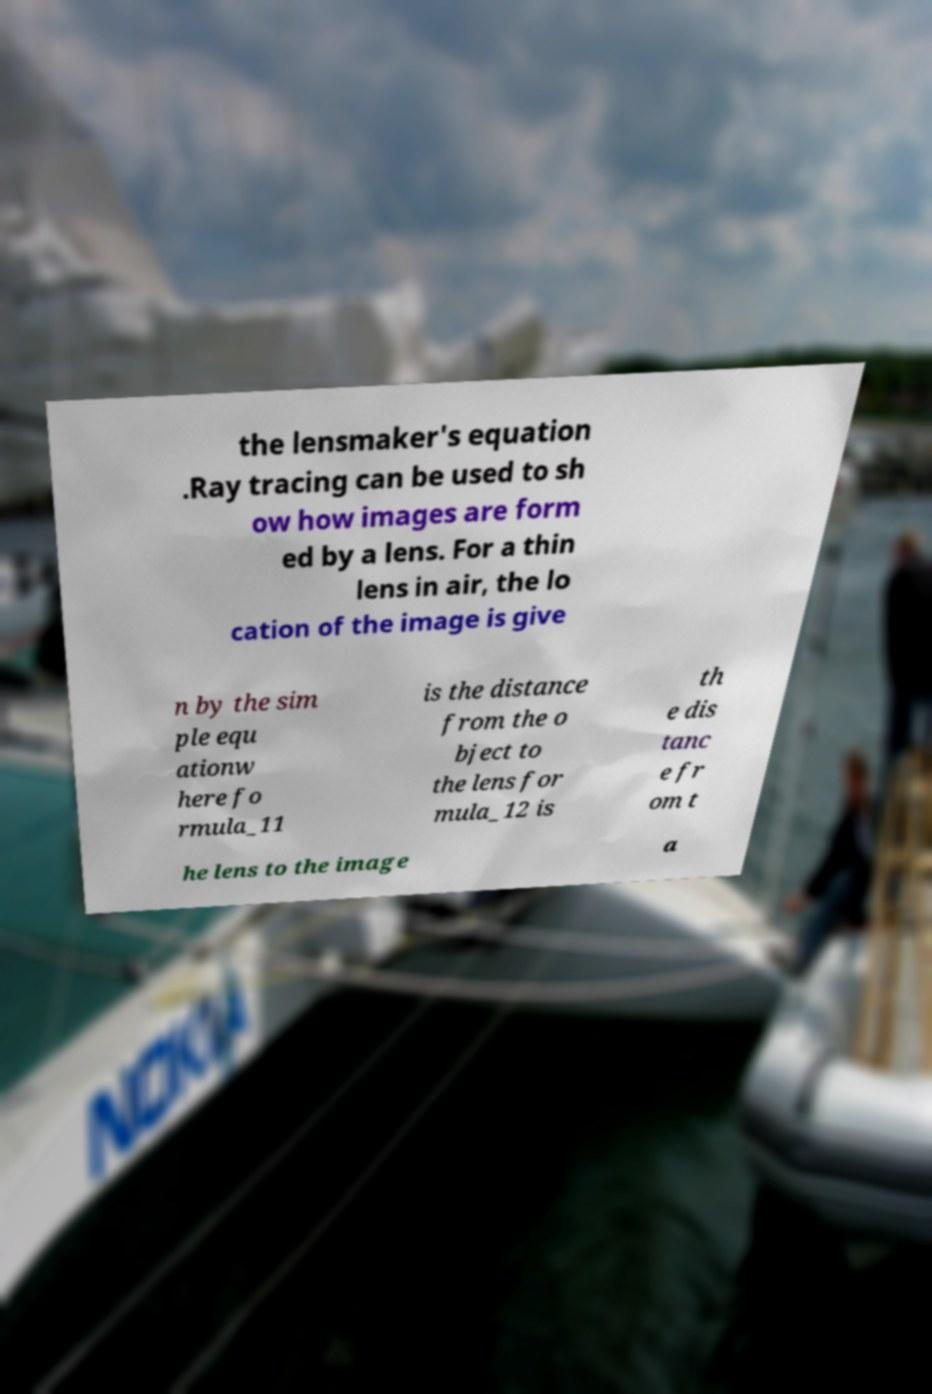Can you read and provide the text displayed in the image?This photo seems to have some interesting text. Can you extract and type it out for me? the lensmaker's equation .Ray tracing can be used to sh ow how images are form ed by a lens. For a thin lens in air, the lo cation of the image is give n by the sim ple equ ationw here fo rmula_11 is the distance from the o bject to the lens for mula_12 is th e dis tanc e fr om t he lens to the image a 